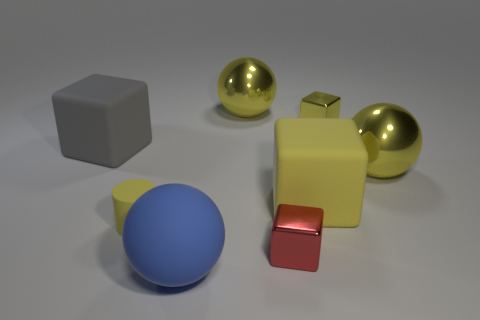Is the number of big gray matte cubes that are on the left side of the small yellow block greater than the number of rubber objects that are behind the large gray object?
Give a very brief answer. Yes. Do the big cube that is left of the yellow cylinder and the tiny yellow thing left of the blue matte sphere have the same material?
Your answer should be very brief. Yes. The red metal object that is the same size as the cylinder is what shape?
Offer a very short reply. Cube. Is there another big thing of the same shape as the blue rubber thing?
Ensure brevity in your answer.  Yes. There is a rubber cylinder behind the tiny red thing; does it have the same color as the small thing right of the small red shiny block?
Your response must be concise. Yes. There is a big blue matte thing; are there any large blocks on the left side of it?
Your answer should be compact. Yes. What is the sphere that is both behind the tiny yellow cylinder and in front of the gray block made of?
Your answer should be compact. Metal. Do the tiny yellow object to the right of the large blue thing and the tiny cylinder have the same material?
Ensure brevity in your answer.  No. What is the material of the large gray thing?
Offer a very short reply. Rubber. What size is the ball that is in front of the matte cylinder?
Your answer should be very brief. Large. 